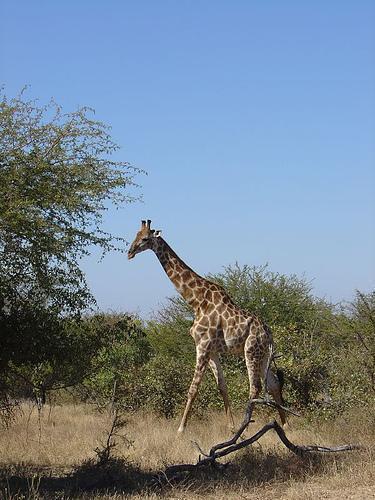How many animals are visible in this photograph?
Give a very brief answer. 1. How many giraffes are there?
Give a very brief answer. 1. 